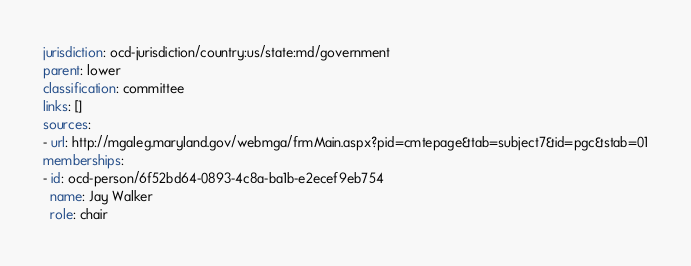Convert code to text. <code><loc_0><loc_0><loc_500><loc_500><_YAML_>jurisdiction: ocd-jurisdiction/country:us/state:md/government
parent: lower
classification: committee
links: []
sources:
- url: http://mgaleg.maryland.gov/webmga/frmMain.aspx?pid=cmtepage&tab=subject7&id=pgc&stab=01
memberships:
- id: ocd-person/6f52bd64-0893-4c8a-ba1b-e2ecef9eb754
  name: Jay Walker
  role: chair
</code> 